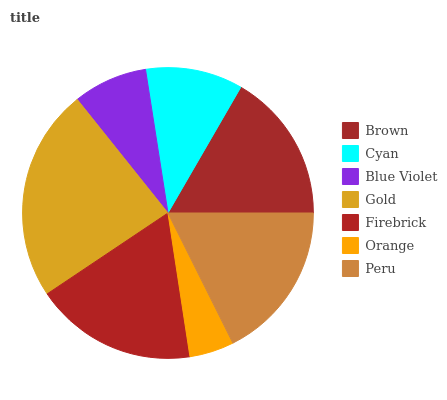Is Orange the minimum?
Answer yes or no. Yes. Is Gold the maximum?
Answer yes or no. Yes. Is Cyan the minimum?
Answer yes or no. No. Is Cyan the maximum?
Answer yes or no. No. Is Brown greater than Cyan?
Answer yes or no. Yes. Is Cyan less than Brown?
Answer yes or no. Yes. Is Cyan greater than Brown?
Answer yes or no. No. Is Brown less than Cyan?
Answer yes or no. No. Is Brown the high median?
Answer yes or no. Yes. Is Brown the low median?
Answer yes or no. Yes. Is Gold the high median?
Answer yes or no. No. Is Peru the low median?
Answer yes or no. No. 